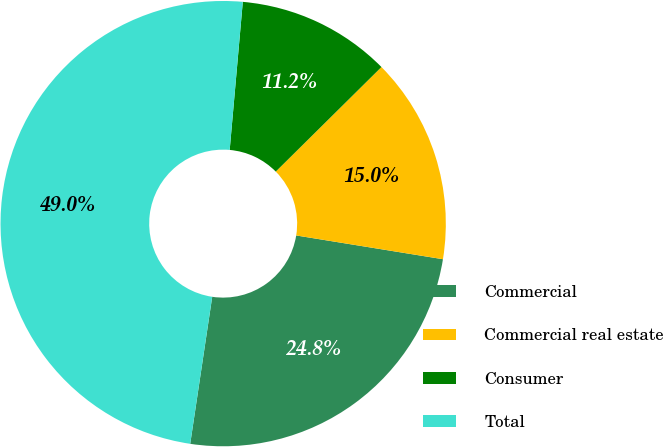Convert chart. <chart><loc_0><loc_0><loc_500><loc_500><pie_chart><fcel>Commercial<fcel>Commercial real estate<fcel>Consumer<fcel>Total<nl><fcel>24.81%<fcel>14.97%<fcel>11.18%<fcel>49.04%<nl></chart> 